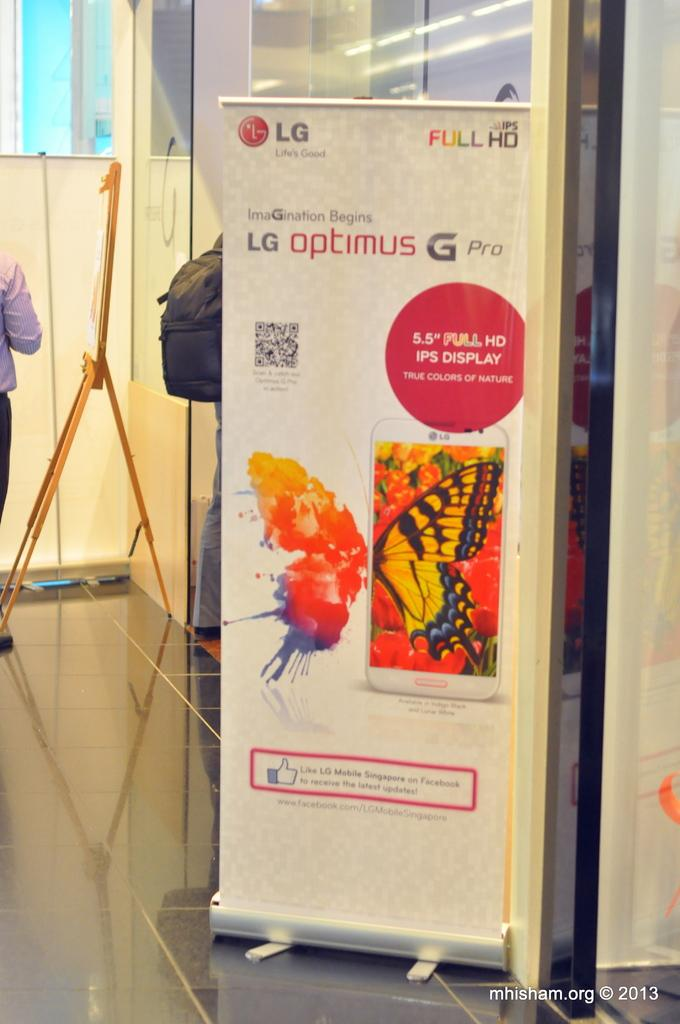Provide a one-sentence caption for the provided image. A banner advertising the visual quality of the LG Optimus G Pro smartphone. 